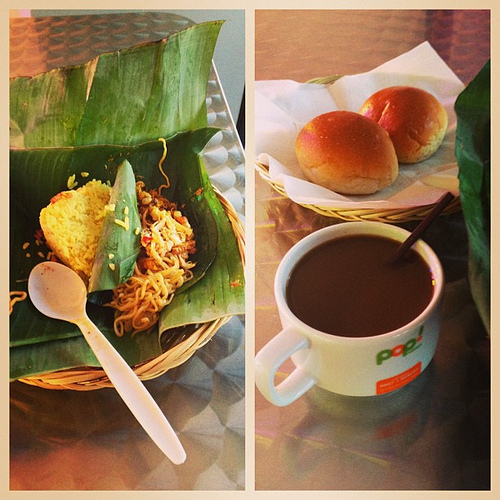In which part is the spoon? The spoon is located in the basket on the left side of the image, amongst what appears to be a serving of noodles. 